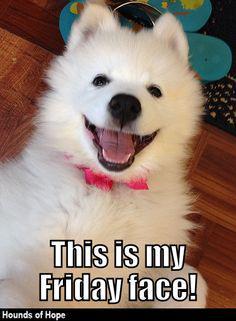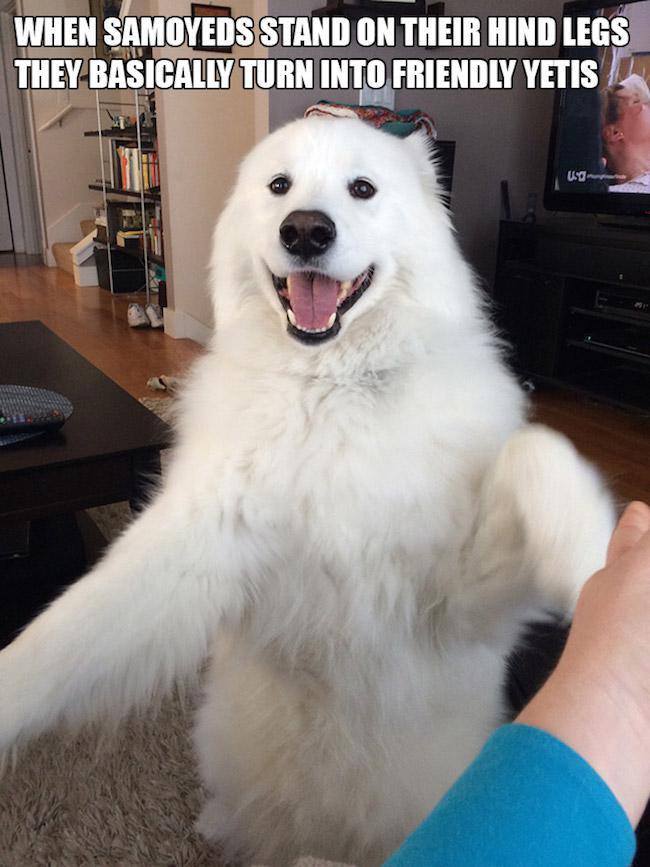The first image is the image on the left, the second image is the image on the right. Considering the images on both sides, is "There are at least three fluffy white dogs." valid? Answer yes or no. No. 